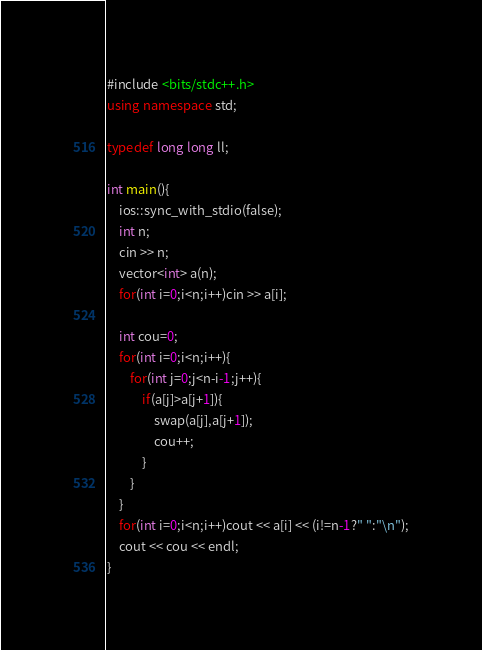Convert code to text. <code><loc_0><loc_0><loc_500><loc_500><_C++_>#include <bits/stdc++.h>
using namespace std;

typedef long long ll;

int main(){
    ios::sync_with_stdio(false);
    int n;
    cin >> n;
    vector<int> a(n);
    for(int i=0;i<n;i++)cin >> a[i];

    int cou=0;
    for(int i=0;i<n;i++){
        for(int j=0;j<n-i-1;j++){
            if(a[j]>a[j+1]){
                swap(a[j],a[j+1]);
                cou++;
            }
        }
    }
    for(int i=0;i<n;i++)cout << a[i] << (i!=n-1?" ":"\n");
    cout << cou << endl;
}

</code> 